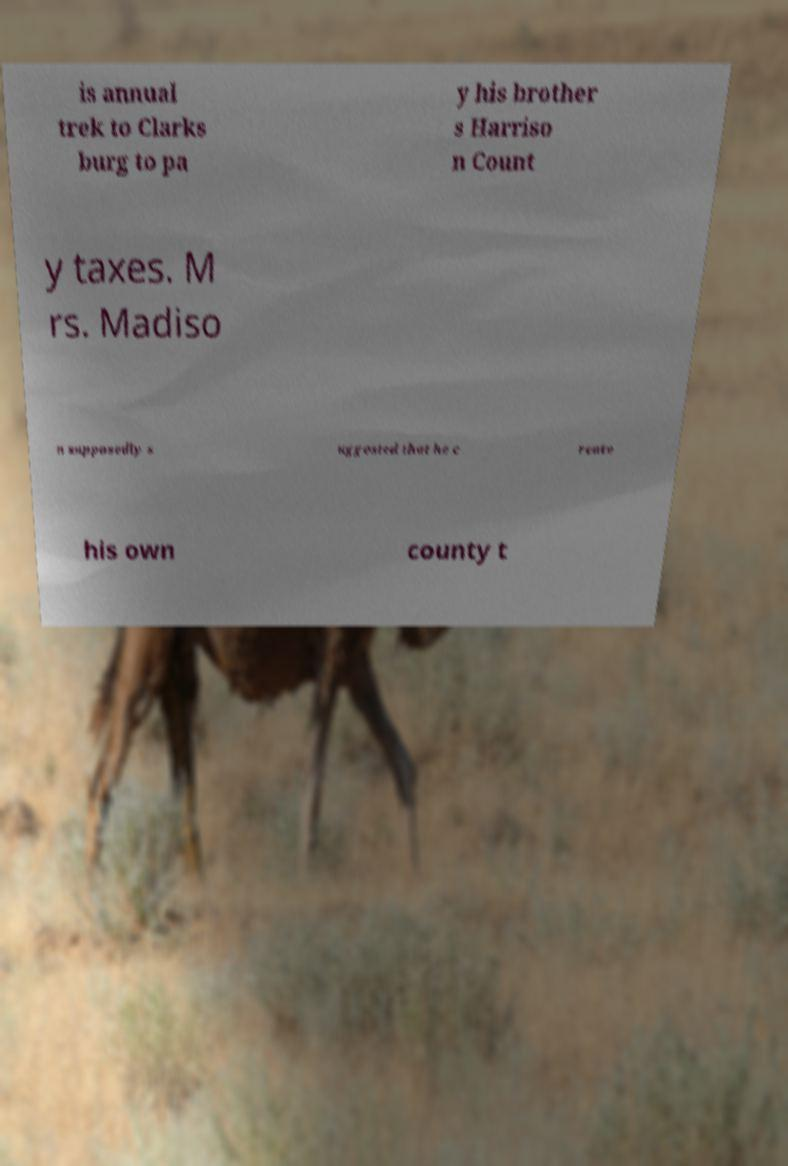I need the written content from this picture converted into text. Can you do that? is annual trek to Clarks burg to pa y his brother s Harriso n Count y taxes. M rs. Madiso n supposedly s uggested that he c reate his own county t 